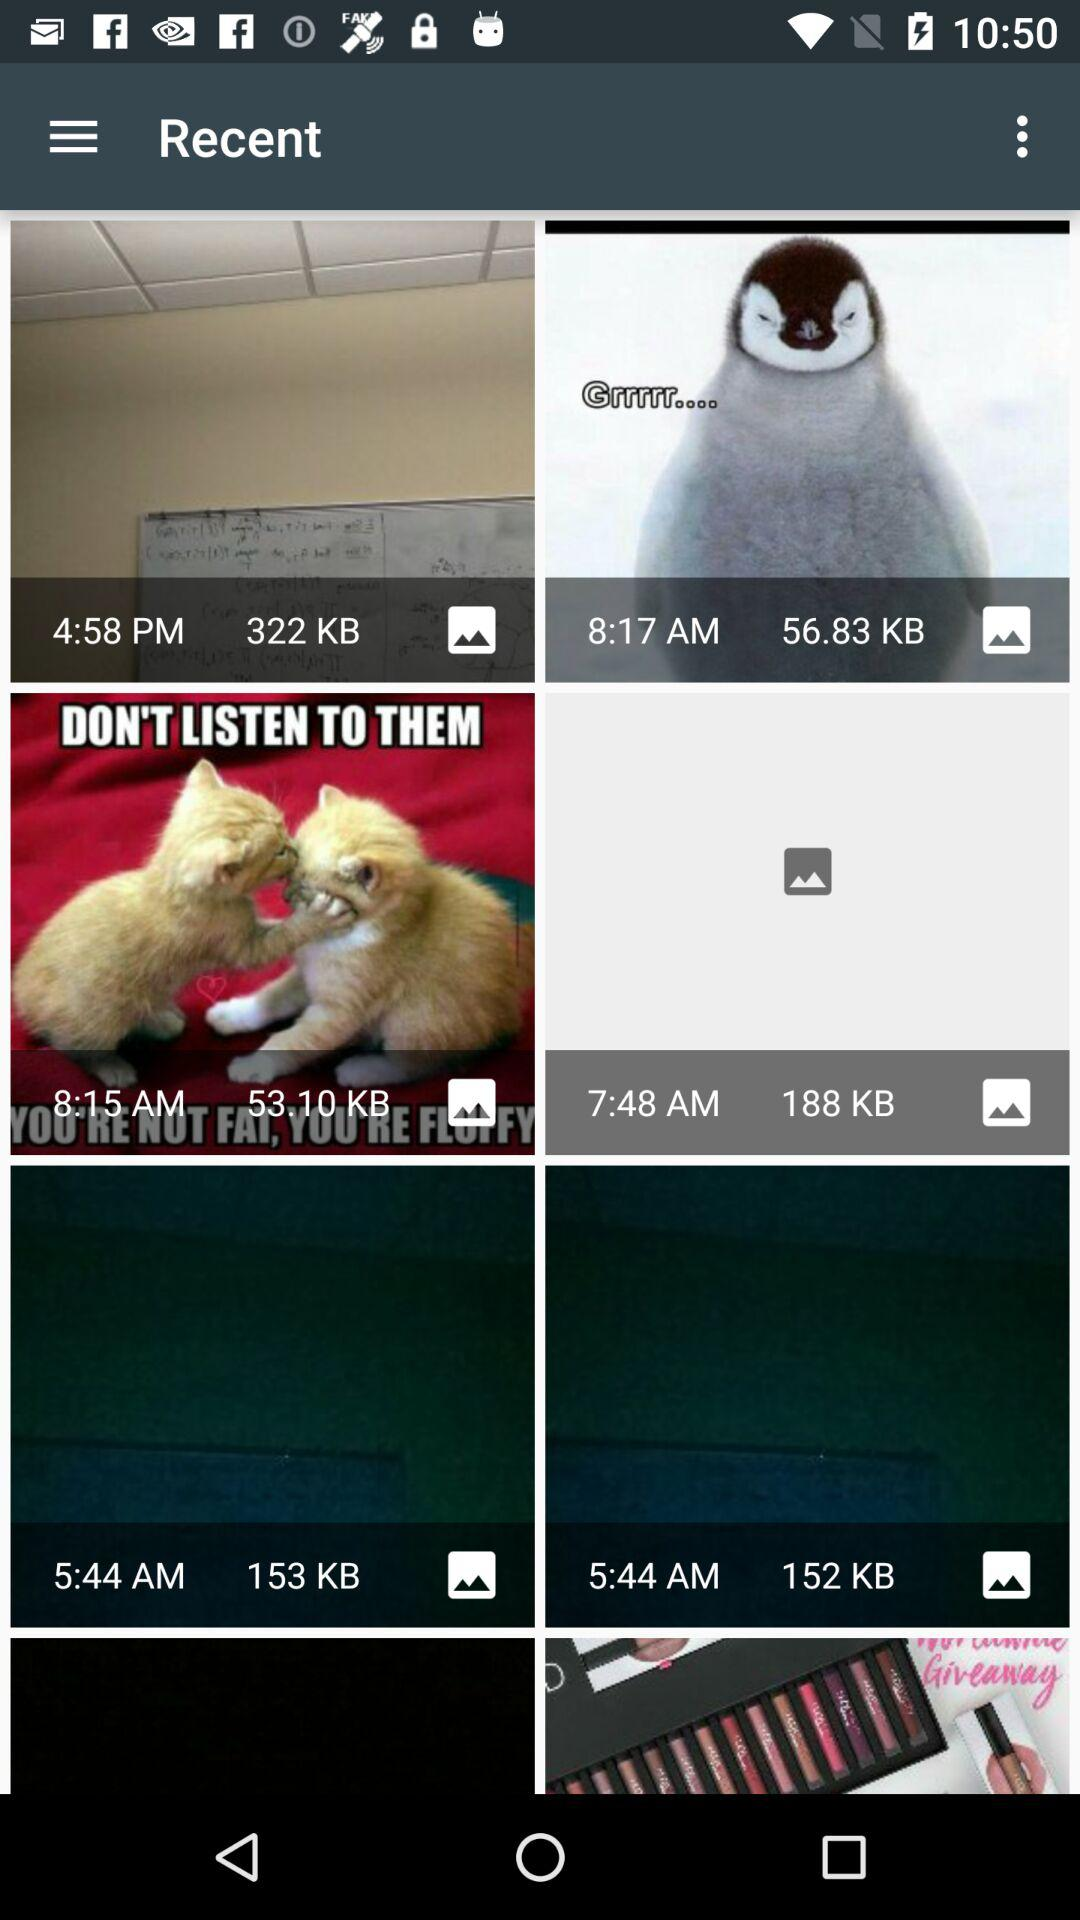Which file has the largest file size?
When the provided information is insufficient, respond with <no answer>. <no answer> 